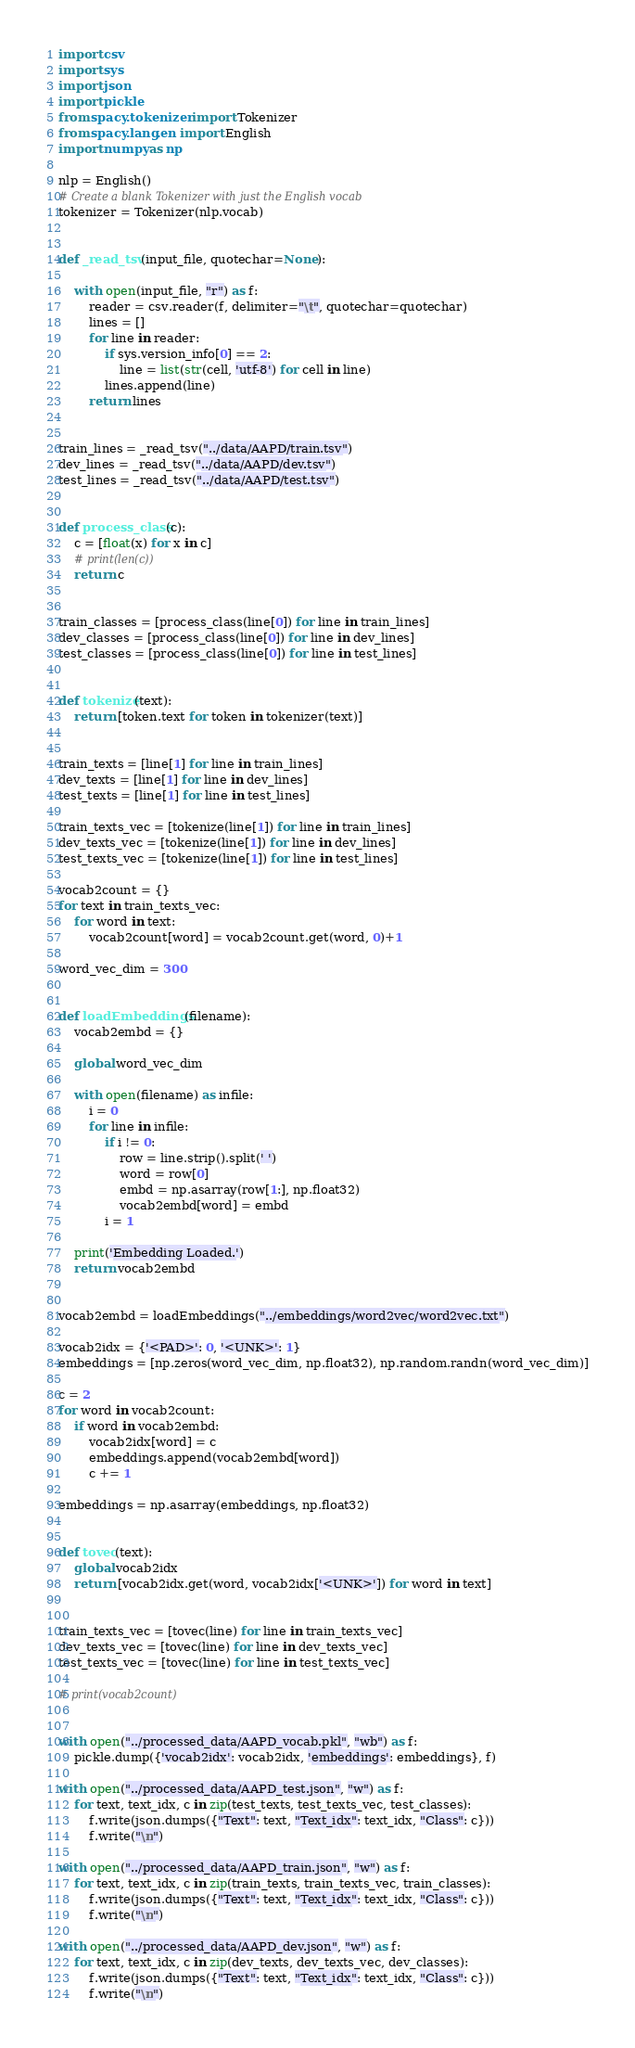<code> <loc_0><loc_0><loc_500><loc_500><_Python_>import csv
import sys
import json
import pickle
from spacy.tokenizer import Tokenizer
from spacy.lang.en import English
import numpy as np

nlp = English()
# Create a blank Tokenizer with just the English vocab
tokenizer = Tokenizer(nlp.vocab)


def _read_tsv(input_file, quotechar=None):

    with open(input_file, "r") as f:
        reader = csv.reader(f, delimiter="\t", quotechar=quotechar)
        lines = []
        for line in reader:
            if sys.version_info[0] == 2:
                line = list(str(cell, 'utf-8') for cell in line)
            lines.append(line)
        return lines


train_lines = _read_tsv("../data/AAPD/train.tsv")
dev_lines = _read_tsv("../data/AAPD/dev.tsv")
test_lines = _read_tsv("../data/AAPD/test.tsv")


def process_class(c):
    c = [float(x) for x in c]
    # print(len(c))
    return c


train_classes = [process_class(line[0]) for line in train_lines]
dev_classes = [process_class(line[0]) for line in dev_lines]
test_classes = [process_class(line[0]) for line in test_lines]


def tokenize(text):
    return [token.text for token in tokenizer(text)]


train_texts = [line[1] for line in train_lines]
dev_texts = [line[1] for line in dev_lines]
test_texts = [line[1] for line in test_lines]

train_texts_vec = [tokenize(line[1]) for line in train_lines]
dev_texts_vec = [tokenize(line[1]) for line in dev_lines]
test_texts_vec = [tokenize(line[1]) for line in test_lines]

vocab2count = {}
for text in train_texts_vec:
    for word in text:
        vocab2count[word] = vocab2count.get(word, 0)+1

word_vec_dim = 300


def loadEmbeddings(filename):
    vocab2embd = {}

    global word_vec_dim

    with open(filename) as infile:
        i = 0
        for line in infile:
            if i != 0:
                row = line.strip().split(' ')
                word = row[0]
                embd = np.asarray(row[1:], np.float32)
                vocab2embd[word] = embd
            i = 1

    print('Embedding Loaded.')
    return vocab2embd


vocab2embd = loadEmbeddings("../embeddings/word2vec/word2vec.txt")

vocab2idx = {'<PAD>': 0, '<UNK>': 1}
embeddings = [np.zeros(word_vec_dim, np.float32), np.random.randn(word_vec_dim)]

c = 2
for word in vocab2count:
    if word in vocab2embd:
        vocab2idx[word] = c
        embeddings.append(vocab2embd[word])
        c += 1

embeddings = np.asarray(embeddings, np.float32)


def tovec(text):
    global vocab2idx
    return [vocab2idx.get(word, vocab2idx['<UNK>']) for word in text]


train_texts_vec = [tovec(line) for line in train_texts_vec]
dev_texts_vec = [tovec(line) for line in dev_texts_vec]
test_texts_vec = [tovec(line) for line in test_texts_vec]

# print(vocab2count)


with open("../processed_data/AAPD_vocab.pkl", "wb") as f:
    pickle.dump({'vocab2idx': vocab2idx, 'embeddings': embeddings}, f)

with open("../processed_data/AAPD_test.json", "w") as f:
    for text, text_idx, c in zip(test_texts, test_texts_vec, test_classes):
        f.write(json.dumps({"Text": text, "Text_idx": text_idx, "Class": c}))
        f.write("\n")

with open("../processed_data/AAPD_train.json", "w") as f:
    for text, text_idx, c in zip(train_texts, train_texts_vec, train_classes):
        f.write(json.dumps({"Text": text, "Text_idx": text_idx, "Class": c}))
        f.write("\n")

with open("../processed_data/AAPD_dev.json", "w") as f:
    for text, text_idx, c in zip(dev_texts, dev_texts_vec, dev_classes):
        f.write(json.dumps({"Text": text, "Text_idx": text_idx, "Class": c}))
        f.write("\n")
</code> 